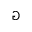<formula> <loc_0><loc_0><loc_500><loc_500>\ G a m e</formula> 